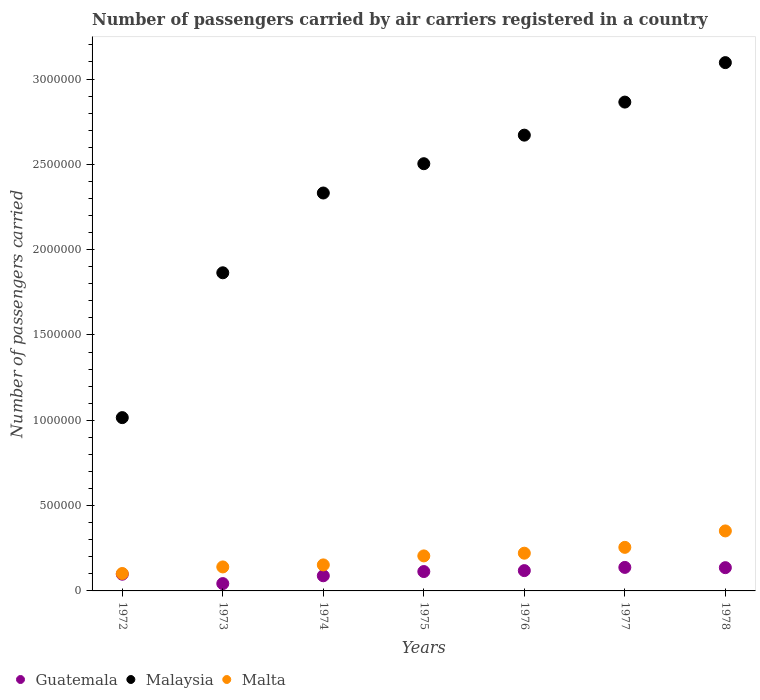How many different coloured dotlines are there?
Make the answer very short. 3. Is the number of dotlines equal to the number of legend labels?
Offer a very short reply. Yes. What is the number of passengers carried by air carriers in Malta in 1974?
Your answer should be very brief. 1.52e+05. Across all years, what is the maximum number of passengers carried by air carriers in Guatemala?
Offer a very short reply. 1.38e+05. Across all years, what is the minimum number of passengers carried by air carriers in Malaysia?
Your answer should be very brief. 1.02e+06. In which year was the number of passengers carried by air carriers in Malaysia maximum?
Your answer should be compact. 1978. What is the total number of passengers carried by air carriers in Malta in the graph?
Your response must be concise. 1.43e+06. What is the difference between the number of passengers carried by air carriers in Malaysia in 1974 and that in 1977?
Provide a succinct answer. -5.33e+05. What is the difference between the number of passengers carried by air carriers in Guatemala in 1978 and the number of passengers carried by air carriers in Malta in 1976?
Ensure brevity in your answer.  -8.48e+04. What is the average number of passengers carried by air carriers in Guatemala per year?
Provide a succinct answer. 1.05e+05. In the year 1978, what is the difference between the number of passengers carried by air carriers in Malaysia and number of passengers carried by air carriers in Malta?
Ensure brevity in your answer.  2.74e+06. What is the ratio of the number of passengers carried by air carriers in Guatemala in 1973 to that in 1977?
Give a very brief answer. 0.31. Is the number of passengers carried by air carriers in Guatemala in 1973 less than that in 1976?
Your answer should be compact. Yes. What is the difference between the highest and the second highest number of passengers carried by air carriers in Malta?
Make the answer very short. 9.63e+04. What is the difference between the highest and the lowest number of passengers carried by air carriers in Malaysia?
Your response must be concise. 2.08e+06. In how many years, is the number of passengers carried by air carriers in Malaysia greater than the average number of passengers carried by air carriers in Malaysia taken over all years?
Make the answer very short. 4. Does the number of passengers carried by air carriers in Guatemala monotonically increase over the years?
Offer a very short reply. No. Is the number of passengers carried by air carriers in Malta strictly greater than the number of passengers carried by air carriers in Guatemala over the years?
Make the answer very short. Yes. How many dotlines are there?
Your answer should be compact. 3. How many years are there in the graph?
Ensure brevity in your answer.  7. Does the graph contain any zero values?
Make the answer very short. No. What is the title of the graph?
Give a very brief answer. Number of passengers carried by air carriers registered in a country. Does "Djibouti" appear as one of the legend labels in the graph?
Give a very brief answer. No. What is the label or title of the Y-axis?
Ensure brevity in your answer.  Number of passengers carried. What is the Number of passengers carried in Guatemala in 1972?
Your answer should be very brief. 9.80e+04. What is the Number of passengers carried of Malaysia in 1972?
Make the answer very short. 1.02e+06. What is the Number of passengers carried of Malta in 1972?
Offer a very short reply. 1.02e+05. What is the Number of passengers carried of Guatemala in 1973?
Ensure brevity in your answer.  4.30e+04. What is the Number of passengers carried of Malaysia in 1973?
Your answer should be very brief. 1.86e+06. What is the Number of passengers carried in Malta in 1973?
Your answer should be compact. 1.41e+05. What is the Number of passengers carried in Guatemala in 1974?
Provide a succinct answer. 8.88e+04. What is the Number of passengers carried of Malaysia in 1974?
Provide a short and direct response. 2.33e+06. What is the Number of passengers carried in Malta in 1974?
Ensure brevity in your answer.  1.52e+05. What is the Number of passengers carried in Guatemala in 1975?
Keep it short and to the point. 1.14e+05. What is the Number of passengers carried of Malaysia in 1975?
Provide a succinct answer. 2.50e+06. What is the Number of passengers carried of Malta in 1975?
Your answer should be very brief. 2.05e+05. What is the Number of passengers carried of Guatemala in 1976?
Ensure brevity in your answer.  1.19e+05. What is the Number of passengers carried of Malaysia in 1976?
Your answer should be compact. 2.67e+06. What is the Number of passengers carried in Malta in 1976?
Offer a very short reply. 2.21e+05. What is the Number of passengers carried in Guatemala in 1977?
Keep it short and to the point. 1.38e+05. What is the Number of passengers carried of Malaysia in 1977?
Keep it short and to the point. 2.86e+06. What is the Number of passengers carried of Malta in 1977?
Keep it short and to the point. 2.55e+05. What is the Number of passengers carried of Guatemala in 1978?
Offer a very short reply. 1.36e+05. What is the Number of passengers carried in Malaysia in 1978?
Offer a terse response. 3.10e+06. What is the Number of passengers carried in Malta in 1978?
Make the answer very short. 3.52e+05. Across all years, what is the maximum Number of passengers carried in Guatemala?
Provide a short and direct response. 1.38e+05. Across all years, what is the maximum Number of passengers carried of Malaysia?
Offer a terse response. 3.10e+06. Across all years, what is the maximum Number of passengers carried in Malta?
Give a very brief answer. 3.52e+05. Across all years, what is the minimum Number of passengers carried of Guatemala?
Make the answer very short. 4.30e+04. Across all years, what is the minimum Number of passengers carried in Malaysia?
Give a very brief answer. 1.02e+06. Across all years, what is the minimum Number of passengers carried in Malta?
Your answer should be compact. 1.02e+05. What is the total Number of passengers carried in Guatemala in the graph?
Provide a succinct answer. 7.36e+05. What is the total Number of passengers carried of Malaysia in the graph?
Keep it short and to the point. 1.63e+07. What is the total Number of passengers carried of Malta in the graph?
Your response must be concise. 1.43e+06. What is the difference between the Number of passengers carried of Guatemala in 1972 and that in 1973?
Provide a succinct answer. 5.50e+04. What is the difference between the Number of passengers carried of Malaysia in 1972 and that in 1973?
Provide a succinct answer. -8.49e+05. What is the difference between the Number of passengers carried of Malta in 1972 and that in 1973?
Offer a terse response. -3.85e+04. What is the difference between the Number of passengers carried of Guatemala in 1972 and that in 1974?
Offer a very short reply. 9200. What is the difference between the Number of passengers carried of Malaysia in 1972 and that in 1974?
Give a very brief answer. -1.32e+06. What is the difference between the Number of passengers carried of Malta in 1972 and that in 1974?
Your response must be concise. -5.04e+04. What is the difference between the Number of passengers carried in Guatemala in 1972 and that in 1975?
Ensure brevity in your answer.  -1.55e+04. What is the difference between the Number of passengers carried of Malaysia in 1972 and that in 1975?
Ensure brevity in your answer.  -1.49e+06. What is the difference between the Number of passengers carried of Malta in 1972 and that in 1975?
Your response must be concise. -1.03e+05. What is the difference between the Number of passengers carried of Guatemala in 1972 and that in 1976?
Give a very brief answer. -2.10e+04. What is the difference between the Number of passengers carried in Malaysia in 1972 and that in 1976?
Offer a terse response. -1.66e+06. What is the difference between the Number of passengers carried of Malta in 1972 and that in 1976?
Your response must be concise. -1.19e+05. What is the difference between the Number of passengers carried in Guatemala in 1972 and that in 1977?
Offer a terse response. -3.98e+04. What is the difference between the Number of passengers carried of Malaysia in 1972 and that in 1977?
Your response must be concise. -1.85e+06. What is the difference between the Number of passengers carried in Malta in 1972 and that in 1977?
Provide a short and direct response. -1.53e+05. What is the difference between the Number of passengers carried of Guatemala in 1972 and that in 1978?
Give a very brief answer. -3.83e+04. What is the difference between the Number of passengers carried of Malaysia in 1972 and that in 1978?
Keep it short and to the point. -2.08e+06. What is the difference between the Number of passengers carried of Malta in 1972 and that in 1978?
Give a very brief answer. -2.50e+05. What is the difference between the Number of passengers carried of Guatemala in 1973 and that in 1974?
Keep it short and to the point. -4.58e+04. What is the difference between the Number of passengers carried in Malaysia in 1973 and that in 1974?
Offer a terse response. -4.68e+05. What is the difference between the Number of passengers carried of Malta in 1973 and that in 1974?
Your answer should be compact. -1.19e+04. What is the difference between the Number of passengers carried of Guatemala in 1973 and that in 1975?
Provide a short and direct response. -7.05e+04. What is the difference between the Number of passengers carried in Malaysia in 1973 and that in 1975?
Provide a short and direct response. -6.39e+05. What is the difference between the Number of passengers carried of Malta in 1973 and that in 1975?
Give a very brief answer. -6.46e+04. What is the difference between the Number of passengers carried in Guatemala in 1973 and that in 1976?
Your response must be concise. -7.60e+04. What is the difference between the Number of passengers carried of Malaysia in 1973 and that in 1976?
Offer a terse response. -8.07e+05. What is the difference between the Number of passengers carried of Malta in 1973 and that in 1976?
Provide a short and direct response. -8.05e+04. What is the difference between the Number of passengers carried of Guatemala in 1973 and that in 1977?
Keep it short and to the point. -9.48e+04. What is the difference between the Number of passengers carried of Malaysia in 1973 and that in 1977?
Make the answer very short. -1.00e+06. What is the difference between the Number of passengers carried in Malta in 1973 and that in 1977?
Your response must be concise. -1.15e+05. What is the difference between the Number of passengers carried of Guatemala in 1973 and that in 1978?
Make the answer very short. -9.33e+04. What is the difference between the Number of passengers carried of Malaysia in 1973 and that in 1978?
Provide a short and direct response. -1.23e+06. What is the difference between the Number of passengers carried in Malta in 1973 and that in 1978?
Your response must be concise. -2.11e+05. What is the difference between the Number of passengers carried in Guatemala in 1974 and that in 1975?
Your answer should be compact. -2.47e+04. What is the difference between the Number of passengers carried in Malaysia in 1974 and that in 1975?
Your response must be concise. -1.72e+05. What is the difference between the Number of passengers carried in Malta in 1974 and that in 1975?
Provide a short and direct response. -5.27e+04. What is the difference between the Number of passengers carried of Guatemala in 1974 and that in 1976?
Your answer should be very brief. -3.02e+04. What is the difference between the Number of passengers carried of Malaysia in 1974 and that in 1976?
Give a very brief answer. -3.39e+05. What is the difference between the Number of passengers carried in Malta in 1974 and that in 1976?
Ensure brevity in your answer.  -6.86e+04. What is the difference between the Number of passengers carried of Guatemala in 1974 and that in 1977?
Offer a very short reply. -4.90e+04. What is the difference between the Number of passengers carried of Malaysia in 1974 and that in 1977?
Provide a succinct answer. -5.33e+05. What is the difference between the Number of passengers carried in Malta in 1974 and that in 1977?
Your response must be concise. -1.03e+05. What is the difference between the Number of passengers carried in Guatemala in 1974 and that in 1978?
Offer a very short reply. -4.75e+04. What is the difference between the Number of passengers carried of Malaysia in 1974 and that in 1978?
Make the answer very short. -7.64e+05. What is the difference between the Number of passengers carried of Malta in 1974 and that in 1978?
Ensure brevity in your answer.  -1.99e+05. What is the difference between the Number of passengers carried in Guatemala in 1975 and that in 1976?
Ensure brevity in your answer.  -5500. What is the difference between the Number of passengers carried of Malaysia in 1975 and that in 1976?
Your answer should be very brief. -1.67e+05. What is the difference between the Number of passengers carried of Malta in 1975 and that in 1976?
Your answer should be very brief. -1.59e+04. What is the difference between the Number of passengers carried in Guatemala in 1975 and that in 1977?
Offer a very short reply. -2.43e+04. What is the difference between the Number of passengers carried in Malaysia in 1975 and that in 1977?
Your answer should be compact. -3.61e+05. What is the difference between the Number of passengers carried in Malta in 1975 and that in 1977?
Keep it short and to the point. -5.01e+04. What is the difference between the Number of passengers carried in Guatemala in 1975 and that in 1978?
Keep it short and to the point. -2.28e+04. What is the difference between the Number of passengers carried of Malaysia in 1975 and that in 1978?
Give a very brief answer. -5.92e+05. What is the difference between the Number of passengers carried in Malta in 1975 and that in 1978?
Provide a succinct answer. -1.46e+05. What is the difference between the Number of passengers carried in Guatemala in 1976 and that in 1977?
Keep it short and to the point. -1.88e+04. What is the difference between the Number of passengers carried of Malaysia in 1976 and that in 1977?
Provide a succinct answer. -1.94e+05. What is the difference between the Number of passengers carried in Malta in 1976 and that in 1977?
Make the answer very short. -3.42e+04. What is the difference between the Number of passengers carried of Guatemala in 1976 and that in 1978?
Offer a very short reply. -1.73e+04. What is the difference between the Number of passengers carried of Malaysia in 1976 and that in 1978?
Your response must be concise. -4.25e+05. What is the difference between the Number of passengers carried of Malta in 1976 and that in 1978?
Provide a succinct answer. -1.30e+05. What is the difference between the Number of passengers carried of Guatemala in 1977 and that in 1978?
Keep it short and to the point. 1500. What is the difference between the Number of passengers carried in Malaysia in 1977 and that in 1978?
Make the answer very short. -2.31e+05. What is the difference between the Number of passengers carried in Malta in 1977 and that in 1978?
Your answer should be compact. -9.63e+04. What is the difference between the Number of passengers carried in Guatemala in 1972 and the Number of passengers carried in Malaysia in 1973?
Keep it short and to the point. -1.77e+06. What is the difference between the Number of passengers carried in Guatemala in 1972 and the Number of passengers carried in Malta in 1973?
Ensure brevity in your answer.  -4.26e+04. What is the difference between the Number of passengers carried in Malaysia in 1972 and the Number of passengers carried in Malta in 1973?
Make the answer very short. 8.75e+05. What is the difference between the Number of passengers carried of Guatemala in 1972 and the Number of passengers carried of Malaysia in 1974?
Keep it short and to the point. -2.23e+06. What is the difference between the Number of passengers carried of Guatemala in 1972 and the Number of passengers carried of Malta in 1974?
Your response must be concise. -5.45e+04. What is the difference between the Number of passengers carried of Malaysia in 1972 and the Number of passengers carried of Malta in 1974?
Give a very brief answer. 8.63e+05. What is the difference between the Number of passengers carried in Guatemala in 1972 and the Number of passengers carried in Malaysia in 1975?
Your answer should be very brief. -2.41e+06. What is the difference between the Number of passengers carried in Guatemala in 1972 and the Number of passengers carried in Malta in 1975?
Keep it short and to the point. -1.07e+05. What is the difference between the Number of passengers carried of Malaysia in 1972 and the Number of passengers carried of Malta in 1975?
Your answer should be compact. 8.10e+05. What is the difference between the Number of passengers carried in Guatemala in 1972 and the Number of passengers carried in Malaysia in 1976?
Your response must be concise. -2.57e+06. What is the difference between the Number of passengers carried in Guatemala in 1972 and the Number of passengers carried in Malta in 1976?
Make the answer very short. -1.23e+05. What is the difference between the Number of passengers carried of Malaysia in 1972 and the Number of passengers carried of Malta in 1976?
Your answer should be compact. 7.94e+05. What is the difference between the Number of passengers carried of Guatemala in 1972 and the Number of passengers carried of Malaysia in 1977?
Your response must be concise. -2.77e+06. What is the difference between the Number of passengers carried of Guatemala in 1972 and the Number of passengers carried of Malta in 1977?
Ensure brevity in your answer.  -1.57e+05. What is the difference between the Number of passengers carried of Malaysia in 1972 and the Number of passengers carried of Malta in 1977?
Your response must be concise. 7.60e+05. What is the difference between the Number of passengers carried in Guatemala in 1972 and the Number of passengers carried in Malaysia in 1978?
Make the answer very short. -3.00e+06. What is the difference between the Number of passengers carried in Guatemala in 1972 and the Number of passengers carried in Malta in 1978?
Your answer should be very brief. -2.54e+05. What is the difference between the Number of passengers carried of Malaysia in 1972 and the Number of passengers carried of Malta in 1978?
Your answer should be compact. 6.64e+05. What is the difference between the Number of passengers carried of Guatemala in 1973 and the Number of passengers carried of Malaysia in 1974?
Provide a short and direct response. -2.29e+06. What is the difference between the Number of passengers carried of Guatemala in 1973 and the Number of passengers carried of Malta in 1974?
Offer a very short reply. -1.10e+05. What is the difference between the Number of passengers carried of Malaysia in 1973 and the Number of passengers carried of Malta in 1974?
Provide a succinct answer. 1.71e+06. What is the difference between the Number of passengers carried in Guatemala in 1973 and the Number of passengers carried in Malaysia in 1975?
Offer a very short reply. -2.46e+06. What is the difference between the Number of passengers carried in Guatemala in 1973 and the Number of passengers carried in Malta in 1975?
Ensure brevity in your answer.  -1.62e+05. What is the difference between the Number of passengers carried of Malaysia in 1973 and the Number of passengers carried of Malta in 1975?
Your response must be concise. 1.66e+06. What is the difference between the Number of passengers carried of Guatemala in 1973 and the Number of passengers carried of Malaysia in 1976?
Your response must be concise. -2.63e+06. What is the difference between the Number of passengers carried of Guatemala in 1973 and the Number of passengers carried of Malta in 1976?
Give a very brief answer. -1.78e+05. What is the difference between the Number of passengers carried in Malaysia in 1973 and the Number of passengers carried in Malta in 1976?
Your answer should be compact. 1.64e+06. What is the difference between the Number of passengers carried of Guatemala in 1973 and the Number of passengers carried of Malaysia in 1977?
Your answer should be very brief. -2.82e+06. What is the difference between the Number of passengers carried in Guatemala in 1973 and the Number of passengers carried in Malta in 1977?
Your response must be concise. -2.12e+05. What is the difference between the Number of passengers carried of Malaysia in 1973 and the Number of passengers carried of Malta in 1977?
Provide a short and direct response. 1.61e+06. What is the difference between the Number of passengers carried of Guatemala in 1973 and the Number of passengers carried of Malaysia in 1978?
Give a very brief answer. -3.05e+06. What is the difference between the Number of passengers carried of Guatemala in 1973 and the Number of passengers carried of Malta in 1978?
Provide a succinct answer. -3.09e+05. What is the difference between the Number of passengers carried of Malaysia in 1973 and the Number of passengers carried of Malta in 1978?
Offer a terse response. 1.51e+06. What is the difference between the Number of passengers carried in Guatemala in 1974 and the Number of passengers carried in Malaysia in 1975?
Provide a short and direct response. -2.41e+06. What is the difference between the Number of passengers carried in Guatemala in 1974 and the Number of passengers carried in Malta in 1975?
Your answer should be very brief. -1.16e+05. What is the difference between the Number of passengers carried of Malaysia in 1974 and the Number of passengers carried of Malta in 1975?
Ensure brevity in your answer.  2.13e+06. What is the difference between the Number of passengers carried of Guatemala in 1974 and the Number of passengers carried of Malaysia in 1976?
Keep it short and to the point. -2.58e+06. What is the difference between the Number of passengers carried of Guatemala in 1974 and the Number of passengers carried of Malta in 1976?
Offer a very short reply. -1.32e+05. What is the difference between the Number of passengers carried in Malaysia in 1974 and the Number of passengers carried in Malta in 1976?
Your response must be concise. 2.11e+06. What is the difference between the Number of passengers carried in Guatemala in 1974 and the Number of passengers carried in Malaysia in 1977?
Your response must be concise. -2.78e+06. What is the difference between the Number of passengers carried in Guatemala in 1974 and the Number of passengers carried in Malta in 1977?
Your response must be concise. -1.66e+05. What is the difference between the Number of passengers carried of Malaysia in 1974 and the Number of passengers carried of Malta in 1977?
Your answer should be very brief. 2.08e+06. What is the difference between the Number of passengers carried in Guatemala in 1974 and the Number of passengers carried in Malaysia in 1978?
Provide a short and direct response. -3.01e+06. What is the difference between the Number of passengers carried of Guatemala in 1974 and the Number of passengers carried of Malta in 1978?
Offer a very short reply. -2.63e+05. What is the difference between the Number of passengers carried in Malaysia in 1974 and the Number of passengers carried in Malta in 1978?
Ensure brevity in your answer.  1.98e+06. What is the difference between the Number of passengers carried of Guatemala in 1975 and the Number of passengers carried of Malaysia in 1976?
Ensure brevity in your answer.  -2.56e+06. What is the difference between the Number of passengers carried of Guatemala in 1975 and the Number of passengers carried of Malta in 1976?
Provide a succinct answer. -1.08e+05. What is the difference between the Number of passengers carried in Malaysia in 1975 and the Number of passengers carried in Malta in 1976?
Your response must be concise. 2.28e+06. What is the difference between the Number of passengers carried of Guatemala in 1975 and the Number of passengers carried of Malaysia in 1977?
Give a very brief answer. -2.75e+06. What is the difference between the Number of passengers carried in Guatemala in 1975 and the Number of passengers carried in Malta in 1977?
Ensure brevity in your answer.  -1.42e+05. What is the difference between the Number of passengers carried of Malaysia in 1975 and the Number of passengers carried of Malta in 1977?
Provide a short and direct response. 2.25e+06. What is the difference between the Number of passengers carried in Guatemala in 1975 and the Number of passengers carried in Malaysia in 1978?
Your response must be concise. -2.98e+06. What is the difference between the Number of passengers carried of Guatemala in 1975 and the Number of passengers carried of Malta in 1978?
Ensure brevity in your answer.  -2.38e+05. What is the difference between the Number of passengers carried in Malaysia in 1975 and the Number of passengers carried in Malta in 1978?
Your answer should be very brief. 2.15e+06. What is the difference between the Number of passengers carried of Guatemala in 1976 and the Number of passengers carried of Malaysia in 1977?
Your answer should be very brief. -2.75e+06. What is the difference between the Number of passengers carried in Guatemala in 1976 and the Number of passengers carried in Malta in 1977?
Provide a short and direct response. -1.36e+05. What is the difference between the Number of passengers carried of Malaysia in 1976 and the Number of passengers carried of Malta in 1977?
Provide a succinct answer. 2.42e+06. What is the difference between the Number of passengers carried in Guatemala in 1976 and the Number of passengers carried in Malaysia in 1978?
Provide a short and direct response. -2.98e+06. What is the difference between the Number of passengers carried of Guatemala in 1976 and the Number of passengers carried of Malta in 1978?
Give a very brief answer. -2.33e+05. What is the difference between the Number of passengers carried of Malaysia in 1976 and the Number of passengers carried of Malta in 1978?
Provide a succinct answer. 2.32e+06. What is the difference between the Number of passengers carried of Guatemala in 1977 and the Number of passengers carried of Malaysia in 1978?
Provide a succinct answer. -2.96e+06. What is the difference between the Number of passengers carried of Guatemala in 1977 and the Number of passengers carried of Malta in 1978?
Keep it short and to the point. -2.14e+05. What is the difference between the Number of passengers carried of Malaysia in 1977 and the Number of passengers carried of Malta in 1978?
Make the answer very short. 2.51e+06. What is the average Number of passengers carried of Guatemala per year?
Offer a very short reply. 1.05e+05. What is the average Number of passengers carried of Malaysia per year?
Make the answer very short. 2.34e+06. What is the average Number of passengers carried of Malta per year?
Provide a succinct answer. 2.04e+05. In the year 1972, what is the difference between the Number of passengers carried in Guatemala and Number of passengers carried in Malaysia?
Your response must be concise. -9.18e+05. In the year 1972, what is the difference between the Number of passengers carried of Guatemala and Number of passengers carried of Malta?
Your answer should be compact. -4100. In the year 1972, what is the difference between the Number of passengers carried in Malaysia and Number of passengers carried in Malta?
Provide a short and direct response. 9.14e+05. In the year 1973, what is the difference between the Number of passengers carried in Guatemala and Number of passengers carried in Malaysia?
Keep it short and to the point. -1.82e+06. In the year 1973, what is the difference between the Number of passengers carried in Guatemala and Number of passengers carried in Malta?
Offer a terse response. -9.76e+04. In the year 1973, what is the difference between the Number of passengers carried of Malaysia and Number of passengers carried of Malta?
Provide a short and direct response. 1.72e+06. In the year 1974, what is the difference between the Number of passengers carried in Guatemala and Number of passengers carried in Malaysia?
Provide a succinct answer. -2.24e+06. In the year 1974, what is the difference between the Number of passengers carried of Guatemala and Number of passengers carried of Malta?
Your response must be concise. -6.37e+04. In the year 1974, what is the difference between the Number of passengers carried of Malaysia and Number of passengers carried of Malta?
Your response must be concise. 2.18e+06. In the year 1975, what is the difference between the Number of passengers carried of Guatemala and Number of passengers carried of Malaysia?
Your answer should be compact. -2.39e+06. In the year 1975, what is the difference between the Number of passengers carried in Guatemala and Number of passengers carried in Malta?
Offer a very short reply. -9.17e+04. In the year 1975, what is the difference between the Number of passengers carried of Malaysia and Number of passengers carried of Malta?
Keep it short and to the point. 2.30e+06. In the year 1976, what is the difference between the Number of passengers carried in Guatemala and Number of passengers carried in Malaysia?
Your response must be concise. -2.55e+06. In the year 1976, what is the difference between the Number of passengers carried in Guatemala and Number of passengers carried in Malta?
Provide a short and direct response. -1.02e+05. In the year 1976, what is the difference between the Number of passengers carried of Malaysia and Number of passengers carried of Malta?
Your response must be concise. 2.45e+06. In the year 1977, what is the difference between the Number of passengers carried of Guatemala and Number of passengers carried of Malaysia?
Ensure brevity in your answer.  -2.73e+06. In the year 1977, what is the difference between the Number of passengers carried of Guatemala and Number of passengers carried of Malta?
Offer a very short reply. -1.18e+05. In the year 1977, what is the difference between the Number of passengers carried of Malaysia and Number of passengers carried of Malta?
Ensure brevity in your answer.  2.61e+06. In the year 1978, what is the difference between the Number of passengers carried in Guatemala and Number of passengers carried in Malaysia?
Ensure brevity in your answer.  -2.96e+06. In the year 1978, what is the difference between the Number of passengers carried of Guatemala and Number of passengers carried of Malta?
Provide a short and direct response. -2.15e+05. In the year 1978, what is the difference between the Number of passengers carried in Malaysia and Number of passengers carried in Malta?
Make the answer very short. 2.74e+06. What is the ratio of the Number of passengers carried of Guatemala in 1972 to that in 1973?
Give a very brief answer. 2.28. What is the ratio of the Number of passengers carried of Malaysia in 1972 to that in 1973?
Keep it short and to the point. 0.54. What is the ratio of the Number of passengers carried of Malta in 1972 to that in 1973?
Give a very brief answer. 0.73. What is the ratio of the Number of passengers carried in Guatemala in 1972 to that in 1974?
Ensure brevity in your answer.  1.1. What is the ratio of the Number of passengers carried in Malaysia in 1972 to that in 1974?
Provide a short and direct response. 0.44. What is the ratio of the Number of passengers carried in Malta in 1972 to that in 1974?
Your answer should be compact. 0.67. What is the ratio of the Number of passengers carried in Guatemala in 1972 to that in 1975?
Your answer should be very brief. 0.86. What is the ratio of the Number of passengers carried of Malaysia in 1972 to that in 1975?
Offer a very short reply. 0.41. What is the ratio of the Number of passengers carried of Malta in 1972 to that in 1975?
Your answer should be compact. 0.5. What is the ratio of the Number of passengers carried of Guatemala in 1972 to that in 1976?
Provide a short and direct response. 0.82. What is the ratio of the Number of passengers carried of Malaysia in 1972 to that in 1976?
Your response must be concise. 0.38. What is the ratio of the Number of passengers carried of Malta in 1972 to that in 1976?
Give a very brief answer. 0.46. What is the ratio of the Number of passengers carried of Guatemala in 1972 to that in 1977?
Your answer should be compact. 0.71. What is the ratio of the Number of passengers carried in Malaysia in 1972 to that in 1977?
Keep it short and to the point. 0.35. What is the ratio of the Number of passengers carried in Malta in 1972 to that in 1977?
Ensure brevity in your answer.  0.4. What is the ratio of the Number of passengers carried of Guatemala in 1972 to that in 1978?
Ensure brevity in your answer.  0.72. What is the ratio of the Number of passengers carried of Malaysia in 1972 to that in 1978?
Make the answer very short. 0.33. What is the ratio of the Number of passengers carried of Malta in 1972 to that in 1978?
Your answer should be very brief. 0.29. What is the ratio of the Number of passengers carried in Guatemala in 1973 to that in 1974?
Provide a short and direct response. 0.48. What is the ratio of the Number of passengers carried of Malaysia in 1973 to that in 1974?
Your response must be concise. 0.8. What is the ratio of the Number of passengers carried of Malta in 1973 to that in 1974?
Your answer should be very brief. 0.92. What is the ratio of the Number of passengers carried of Guatemala in 1973 to that in 1975?
Keep it short and to the point. 0.38. What is the ratio of the Number of passengers carried of Malaysia in 1973 to that in 1975?
Give a very brief answer. 0.74. What is the ratio of the Number of passengers carried in Malta in 1973 to that in 1975?
Offer a very short reply. 0.69. What is the ratio of the Number of passengers carried of Guatemala in 1973 to that in 1976?
Offer a very short reply. 0.36. What is the ratio of the Number of passengers carried of Malaysia in 1973 to that in 1976?
Keep it short and to the point. 0.7. What is the ratio of the Number of passengers carried of Malta in 1973 to that in 1976?
Your answer should be compact. 0.64. What is the ratio of the Number of passengers carried of Guatemala in 1973 to that in 1977?
Make the answer very short. 0.31. What is the ratio of the Number of passengers carried in Malaysia in 1973 to that in 1977?
Make the answer very short. 0.65. What is the ratio of the Number of passengers carried in Malta in 1973 to that in 1977?
Your response must be concise. 0.55. What is the ratio of the Number of passengers carried in Guatemala in 1973 to that in 1978?
Your answer should be very brief. 0.32. What is the ratio of the Number of passengers carried of Malaysia in 1973 to that in 1978?
Ensure brevity in your answer.  0.6. What is the ratio of the Number of passengers carried of Malta in 1973 to that in 1978?
Offer a very short reply. 0.4. What is the ratio of the Number of passengers carried in Guatemala in 1974 to that in 1975?
Ensure brevity in your answer.  0.78. What is the ratio of the Number of passengers carried of Malaysia in 1974 to that in 1975?
Offer a very short reply. 0.93. What is the ratio of the Number of passengers carried in Malta in 1974 to that in 1975?
Give a very brief answer. 0.74. What is the ratio of the Number of passengers carried in Guatemala in 1974 to that in 1976?
Offer a very short reply. 0.75. What is the ratio of the Number of passengers carried of Malaysia in 1974 to that in 1976?
Make the answer very short. 0.87. What is the ratio of the Number of passengers carried in Malta in 1974 to that in 1976?
Provide a short and direct response. 0.69. What is the ratio of the Number of passengers carried of Guatemala in 1974 to that in 1977?
Your answer should be very brief. 0.64. What is the ratio of the Number of passengers carried of Malaysia in 1974 to that in 1977?
Give a very brief answer. 0.81. What is the ratio of the Number of passengers carried of Malta in 1974 to that in 1977?
Provide a short and direct response. 0.6. What is the ratio of the Number of passengers carried in Guatemala in 1974 to that in 1978?
Provide a short and direct response. 0.65. What is the ratio of the Number of passengers carried in Malaysia in 1974 to that in 1978?
Offer a very short reply. 0.75. What is the ratio of the Number of passengers carried of Malta in 1974 to that in 1978?
Make the answer very short. 0.43. What is the ratio of the Number of passengers carried in Guatemala in 1975 to that in 1976?
Your answer should be compact. 0.95. What is the ratio of the Number of passengers carried of Malaysia in 1975 to that in 1976?
Ensure brevity in your answer.  0.94. What is the ratio of the Number of passengers carried of Malta in 1975 to that in 1976?
Provide a short and direct response. 0.93. What is the ratio of the Number of passengers carried of Guatemala in 1975 to that in 1977?
Give a very brief answer. 0.82. What is the ratio of the Number of passengers carried of Malaysia in 1975 to that in 1977?
Your response must be concise. 0.87. What is the ratio of the Number of passengers carried in Malta in 1975 to that in 1977?
Your answer should be very brief. 0.8. What is the ratio of the Number of passengers carried of Guatemala in 1975 to that in 1978?
Provide a succinct answer. 0.83. What is the ratio of the Number of passengers carried in Malaysia in 1975 to that in 1978?
Provide a short and direct response. 0.81. What is the ratio of the Number of passengers carried of Malta in 1975 to that in 1978?
Give a very brief answer. 0.58. What is the ratio of the Number of passengers carried of Guatemala in 1976 to that in 1977?
Offer a very short reply. 0.86. What is the ratio of the Number of passengers carried in Malaysia in 1976 to that in 1977?
Offer a very short reply. 0.93. What is the ratio of the Number of passengers carried of Malta in 1976 to that in 1977?
Provide a succinct answer. 0.87. What is the ratio of the Number of passengers carried of Guatemala in 1976 to that in 1978?
Your response must be concise. 0.87. What is the ratio of the Number of passengers carried in Malaysia in 1976 to that in 1978?
Make the answer very short. 0.86. What is the ratio of the Number of passengers carried in Malta in 1976 to that in 1978?
Provide a short and direct response. 0.63. What is the ratio of the Number of passengers carried in Guatemala in 1977 to that in 1978?
Your response must be concise. 1.01. What is the ratio of the Number of passengers carried in Malaysia in 1977 to that in 1978?
Your answer should be compact. 0.93. What is the ratio of the Number of passengers carried of Malta in 1977 to that in 1978?
Your answer should be compact. 0.73. What is the difference between the highest and the second highest Number of passengers carried in Guatemala?
Provide a succinct answer. 1500. What is the difference between the highest and the second highest Number of passengers carried in Malaysia?
Offer a very short reply. 2.31e+05. What is the difference between the highest and the second highest Number of passengers carried of Malta?
Make the answer very short. 9.63e+04. What is the difference between the highest and the lowest Number of passengers carried in Guatemala?
Your answer should be very brief. 9.48e+04. What is the difference between the highest and the lowest Number of passengers carried of Malaysia?
Offer a terse response. 2.08e+06. What is the difference between the highest and the lowest Number of passengers carried of Malta?
Give a very brief answer. 2.50e+05. 